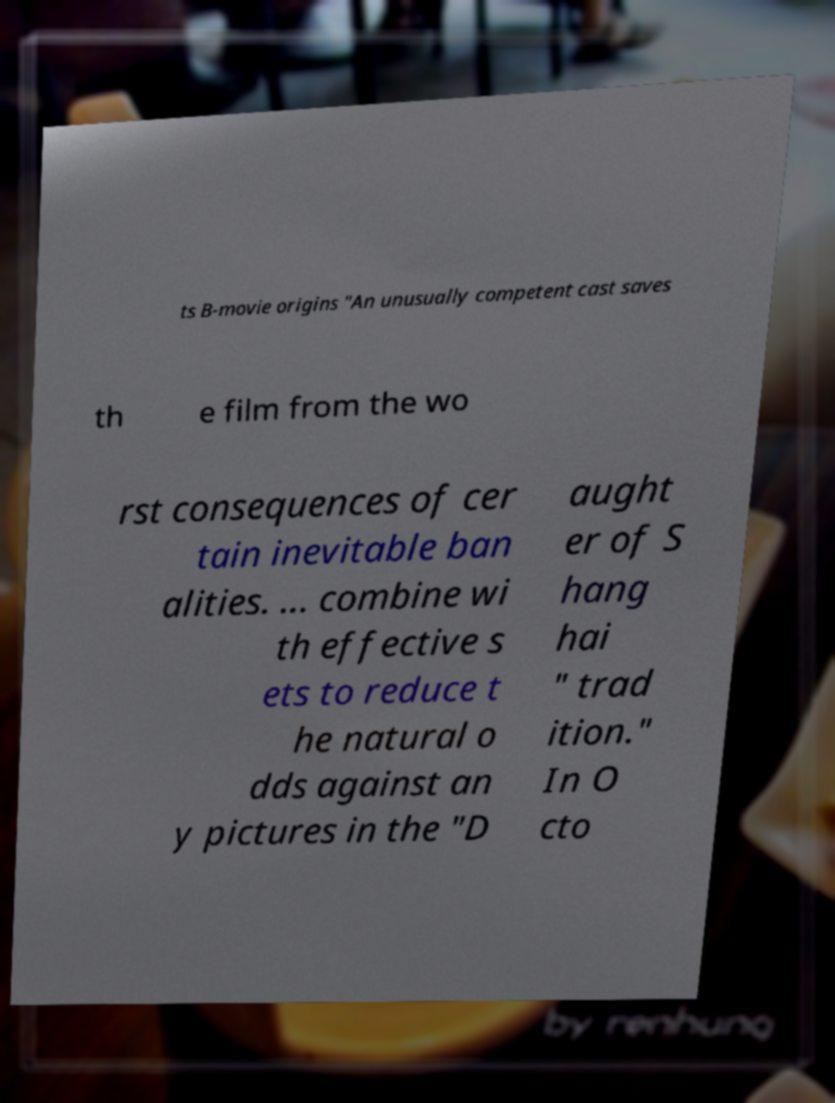For documentation purposes, I need the text within this image transcribed. Could you provide that? ts B-movie origins "An unusually competent cast saves th e film from the wo rst consequences of cer tain inevitable ban alities. ... combine wi th effective s ets to reduce t he natural o dds against an y pictures in the "D aught er of S hang hai " trad ition." In O cto 